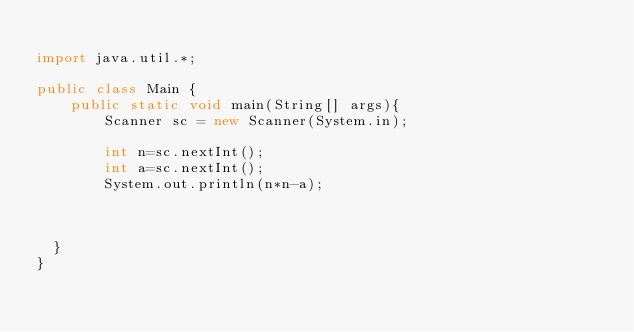Convert code to text. <code><loc_0><loc_0><loc_500><loc_500><_Java_>
import java.util.*;

public class Main {
	public static void main(String[] args){
		Scanner sc = new Scanner(System.in);

		int n=sc.nextInt();
		int a=sc.nextInt();
		System.out.println(n*n-a);
		
		

  }
}
</code> 